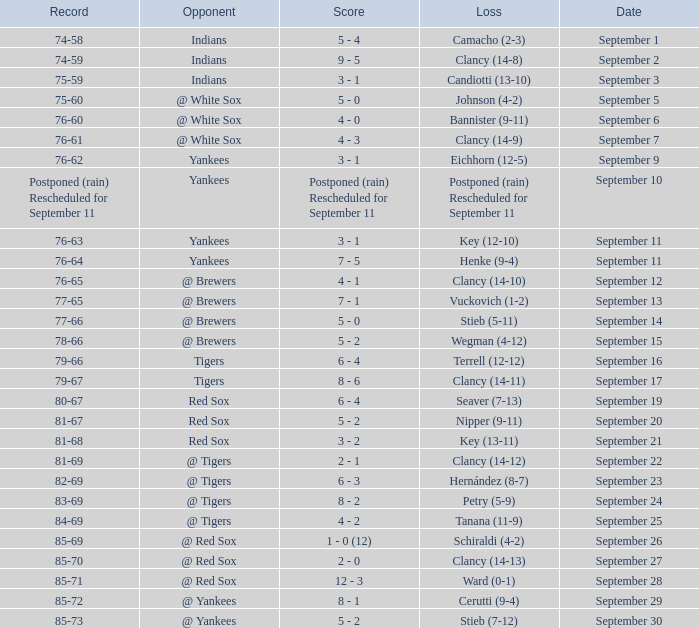Parse the table in full. {'header': ['Record', 'Opponent', 'Score', 'Loss', 'Date'], 'rows': [['74-58', 'Indians', '5 - 4', 'Camacho (2-3)', 'September 1'], ['74-59', 'Indians', '9 - 5', 'Clancy (14-8)', 'September 2'], ['75-59', 'Indians', '3 - 1', 'Candiotti (13-10)', 'September 3'], ['75-60', '@ White Sox', '5 - 0', 'Johnson (4-2)', 'September 5'], ['76-60', '@ White Sox', '4 - 0', 'Bannister (9-11)', 'September 6'], ['76-61', '@ White Sox', '4 - 3', 'Clancy (14-9)', 'September 7'], ['76-62', 'Yankees', '3 - 1', 'Eichhorn (12-5)', 'September 9'], ['Postponed (rain) Rescheduled for September 11', 'Yankees', 'Postponed (rain) Rescheduled for September 11', 'Postponed (rain) Rescheduled for September 11', 'September 10'], ['76-63', 'Yankees', '3 - 1', 'Key (12-10)', 'September 11'], ['76-64', 'Yankees', '7 - 5', 'Henke (9-4)', 'September 11'], ['76-65', '@ Brewers', '4 - 1', 'Clancy (14-10)', 'September 12'], ['77-65', '@ Brewers', '7 - 1', 'Vuckovich (1-2)', 'September 13'], ['77-66', '@ Brewers', '5 - 0', 'Stieb (5-11)', 'September 14'], ['78-66', '@ Brewers', '5 - 2', 'Wegman (4-12)', 'September 15'], ['79-66', 'Tigers', '6 - 4', 'Terrell (12-12)', 'September 16'], ['79-67', 'Tigers', '8 - 6', 'Clancy (14-11)', 'September 17'], ['80-67', 'Red Sox', '6 - 4', 'Seaver (7-13)', 'September 19'], ['81-67', 'Red Sox', '5 - 2', 'Nipper (9-11)', 'September 20'], ['81-68', 'Red Sox', '3 - 2', 'Key (13-11)', 'September 21'], ['81-69', '@ Tigers', '2 - 1', 'Clancy (14-12)', 'September 22'], ['82-69', '@ Tigers', '6 - 3', 'Hernández (8-7)', 'September 23'], ['83-69', '@ Tigers', '8 - 2', 'Petry (5-9)', 'September 24'], ['84-69', '@ Tigers', '4 - 2', 'Tanana (11-9)', 'September 25'], ['85-69', '@ Red Sox', '1 - 0 (12)', 'Schiraldi (4-2)', 'September 26'], ['85-70', '@ Red Sox', '2 - 0', 'Clancy (14-13)', 'September 27'], ['85-71', '@ Red Sox', '12 - 3', 'Ward (0-1)', 'September 28'], ['85-72', '@ Yankees', '8 - 1', 'Cerutti (9-4)', 'September 29'], ['85-73', '@ Yankees', '5 - 2', 'Stieb (7-12)', 'September 30']]} What was the date of the game when their record was 84-69? September 25. 